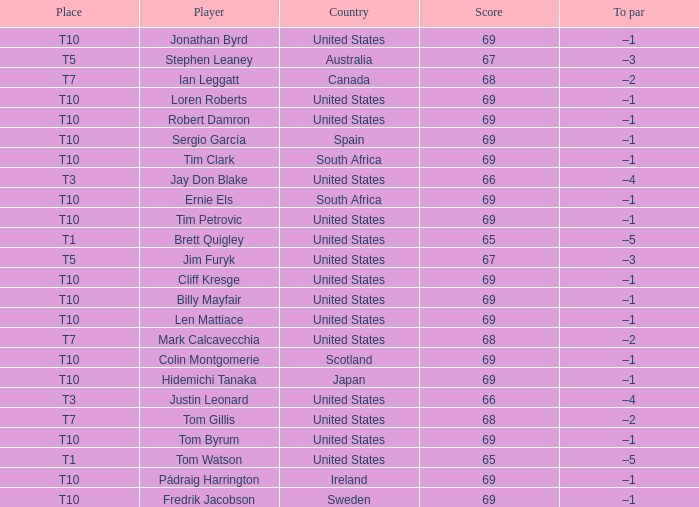What is the average score for the player who is T5 in the United States? 67.0. 